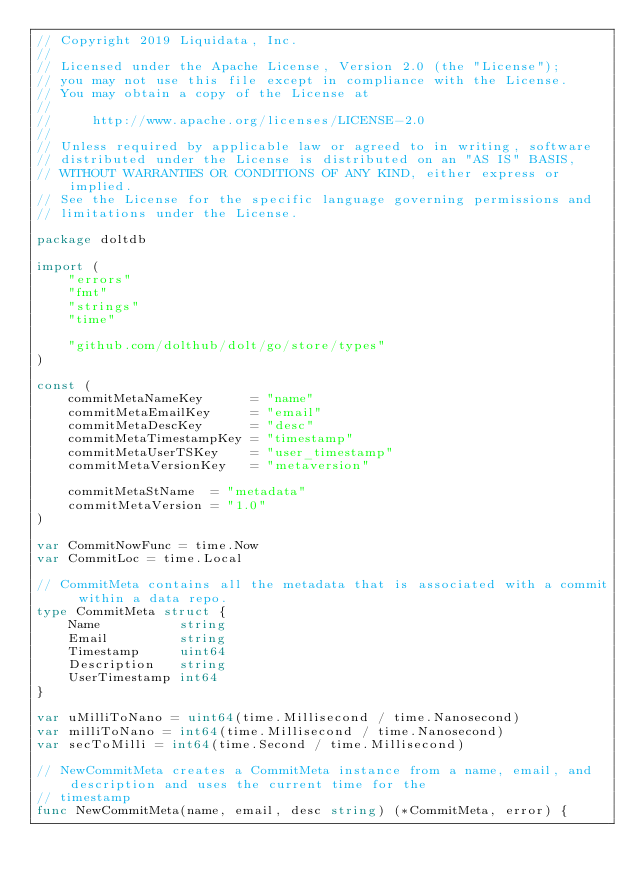<code> <loc_0><loc_0><loc_500><loc_500><_Go_>// Copyright 2019 Liquidata, Inc.
//
// Licensed under the Apache License, Version 2.0 (the "License");
// you may not use this file except in compliance with the License.
// You may obtain a copy of the License at
//
//     http://www.apache.org/licenses/LICENSE-2.0
//
// Unless required by applicable law or agreed to in writing, software
// distributed under the License is distributed on an "AS IS" BASIS,
// WITHOUT WARRANTIES OR CONDITIONS OF ANY KIND, either express or implied.
// See the License for the specific language governing permissions and
// limitations under the License.

package doltdb

import (
	"errors"
	"fmt"
	"strings"
	"time"

	"github.com/dolthub/dolt/go/store/types"
)

const (
	commitMetaNameKey      = "name"
	commitMetaEmailKey     = "email"
	commitMetaDescKey      = "desc"
	commitMetaTimestampKey = "timestamp"
	commitMetaUserTSKey    = "user_timestamp"
	commitMetaVersionKey   = "metaversion"

	commitMetaStName  = "metadata"
	commitMetaVersion = "1.0"
)

var CommitNowFunc = time.Now
var CommitLoc = time.Local

// CommitMeta contains all the metadata that is associated with a commit within a data repo.
type CommitMeta struct {
	Name          string
	Email         string
	Timestamp     uint64
	Description   string
	UserTimestamp int64
}

var uMilliToNano = uint64(time.Millisecond / time.Nanosecond)
var milliToNano = int64(time.Millisecond / time.Nanosecond)
var secToMilli = int64(time.Second / time.Millisecond)

// NewCommitMeta creates a CommitMeta instance from a name, email, and description and uses the current time for the
// timestamp
func NewCommitMeta(name, email, desc string) (*CommitMeta, error) {</code> 